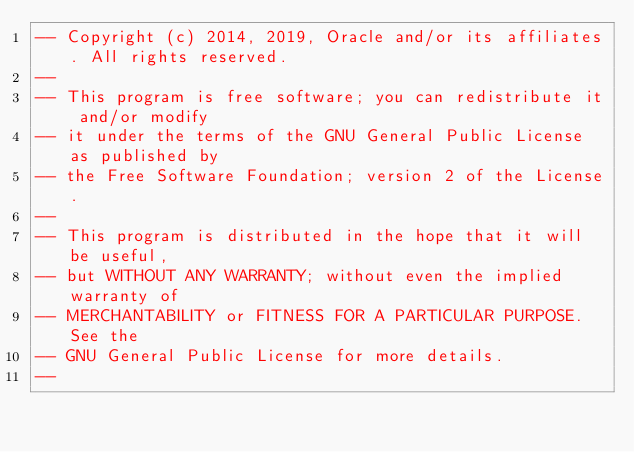<code> <loc_0><loc_0><loc_500><loc_500><_SQL_>-- Copyright (c) 2014, 2019, Oracle and/or its affiliates. All rights reserved.
--
-- This program is free software; you can redistribute it and/or modify
-- it under the terms of the GNU General Public License as published by
-- the Free Software Foundation; version 2 of the License.
--
-- This program is distributed in the hope that it will be useful,
-- but WITHOUT ANY WARRANTY; without even the implied warranty of
-- MERCHANTABILITY or FITNESS FOR A PARTICULAR PURPOSE.  See the
-- GNU General Public License for more details.
--</code> 